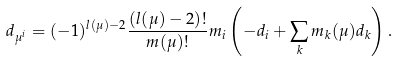<formula> <loc_0><loc_0><loc_500><loc_500>d _ { \mu ^ { i } } = ( - 1 ) ^ { l ( \mu ) - 2 } \frac { ( l ( \mu ) - 2 ) ! } { m ( \mu ) ! } m _ { i } \left ( - d _ { i } + \sum _ { k } m _ { k } ( \mu ) d _ { k } \right ) .</formula> 